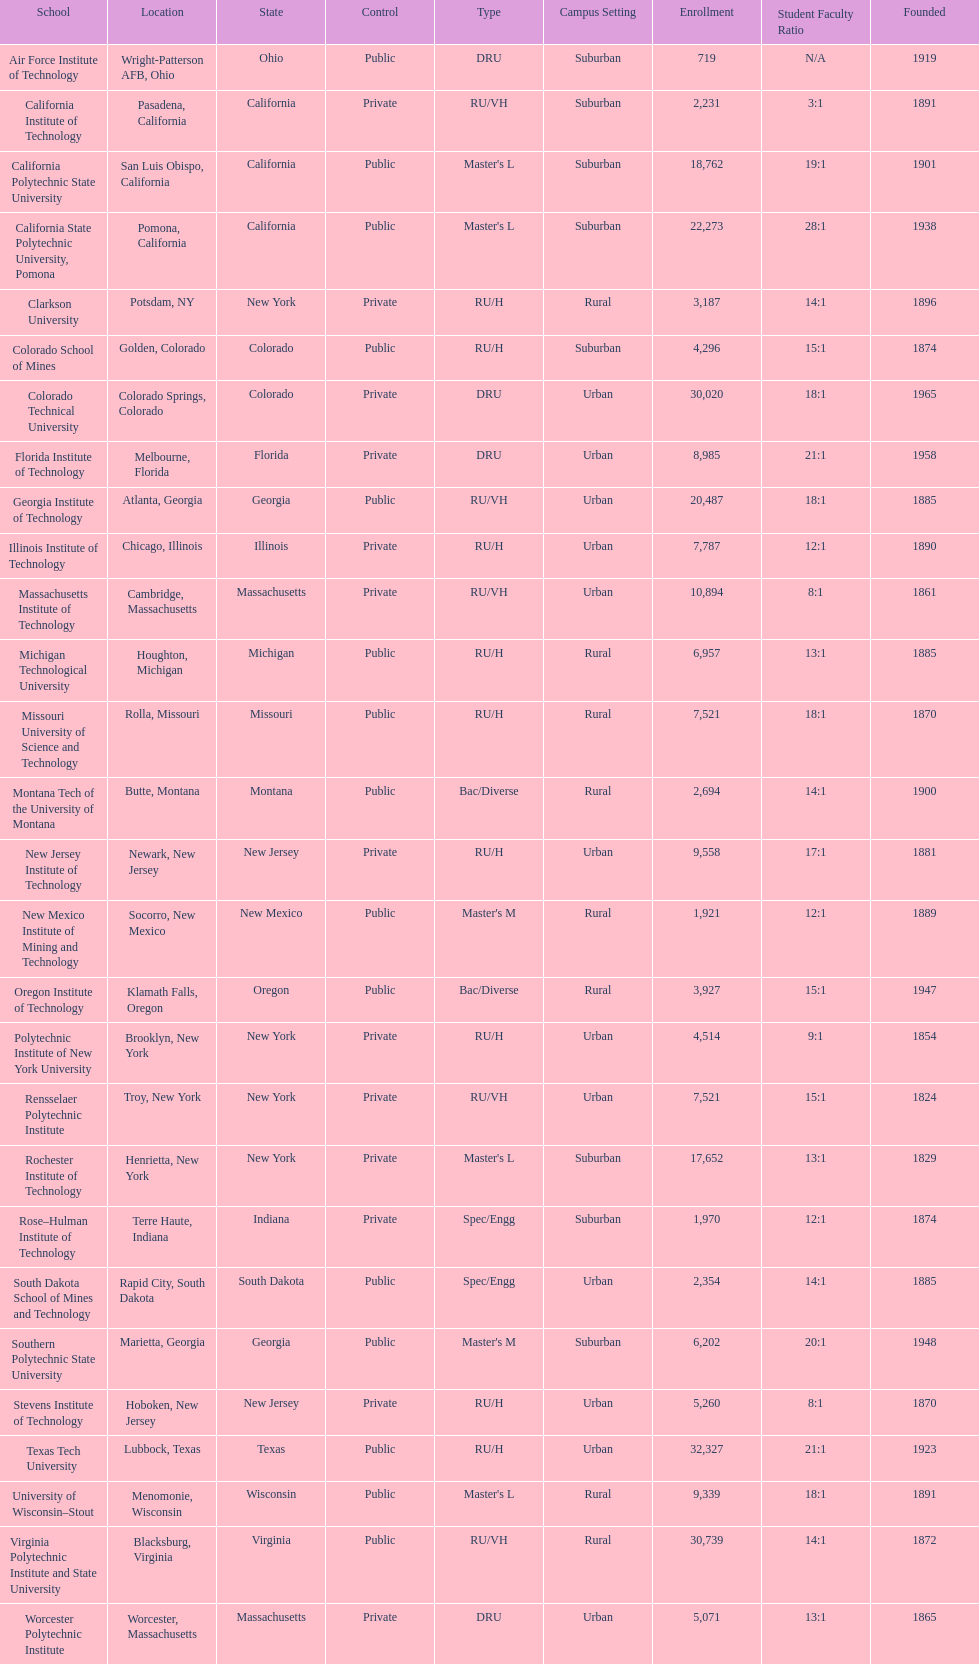Which school had the largest enrollment? Texas Tech University. 